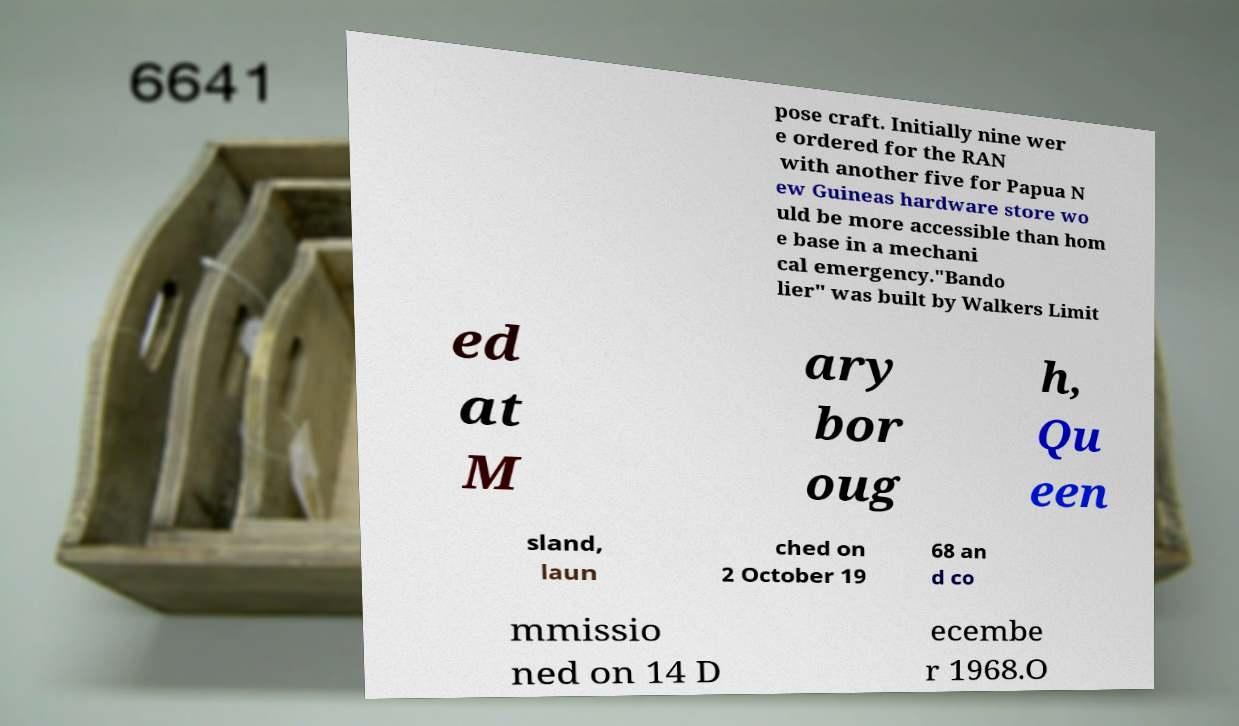Please identify and transcribe the text found in this image. pose craft. Initially nine wer e ordered for the RAN with another five for Papua N ew Guineas hardware store wo uld be more accessible than hom e base in a mechani cal emergency."Bando lier" was built by Walkers Limit ed at M ary bor oug h, Qu een sland, laun ched on 2 October 19 68 an d co mmissio ned on 14 D ecembe r 1968.O 